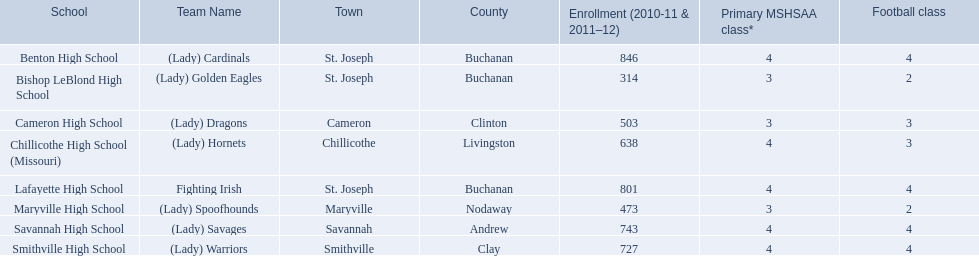Which educational establishments are situated in st. joseph? Benton High School, Bishop LeBlond High School, Lafayette High School. Which st. joseph establishments boast over 800 attendees for 2010-11 and 2011-12? Benton High School, Lafayette High School. What is the designation of the st. joseph establishment with 800 or more attendees whose team names are not a (lady)? Lafayette High School. Can you parse all the data within this table? {'header': ['School', 'Team Name', 'Town', 'County', 'Enrollment (2010-11 & 2011–12)', 'Primary MSHSAA class*', 'Football class'], 'rows': [['Benton High School', '(Lady) Cardinals', 'St. Joseph', 'Buchanan', '846', '4', '4'], ['Bishop LeBlond High School', '(Lady) Golden Eagles', 'St. Joseph', 'Buchanan', '314', '3', '2'], ['Cameron High School', '(Lady) Dragons', 'Cameron', 'Clinton', '503', '3', '3'], ['Chillicothe High School (Missouri)', '(Lady) Hornets', 'Chillicothe', 'Livingston', '638', '4', '3'], ['Lafayette High School', 'Fighting Irish', 'St. Joseph', 'Buchanan', '801', '4', '4'], ['Maryville High School', '(Lady) Spoofhounds', 'Maryville', 'Nodaway', '473', '3', '2'], ['Savannah High School', '(Lady) Savages', 'Savannah', 'Andrew', '743', '4', '4'], ['Smithville High School', '(Lady) Warriors', 'Smithville', 'Clay', '727', '4', '4']]} What is the complete list of schools? Benton High School, Bishop LeBlond High School, Cameron High School, Chillicothe High School (Missouri), Lafayette High School, Maryville High School, Savannah High School, Smithville High School. How many football courses are offered at each school? 4, 2, 3, 3, 4, 2, 4, 4. What is the enrollment at each school? 846, 314, 503, 638, 801, 473, 743, 727. Which of these schools offer three football courses? Cameron High School, Chillicothe High School (Missouri). Among these schools, which one has 638 students enrolled? Chillicothe High School (Missouri). What schools are included in the total list? Benton High School, Bishop LeBlond High School, Cameron High School, Chillicothe High School (Missouri), Lafayette High School, Maryville High School, Savannah High School, Smithville High School. How many football classes are there in each school? 4, 2, 3, 3, 4, 2, 4, 4. What is the student enrollment for each school? 846, 314, 503, 638, 801, 473, 743, 727. Which schools have three football classes offered? Cameron High School, Chillicothe High School (Missouri). Among these schools, which one has an enrollment of 638 students? Chillicothe High School (Missouri). 